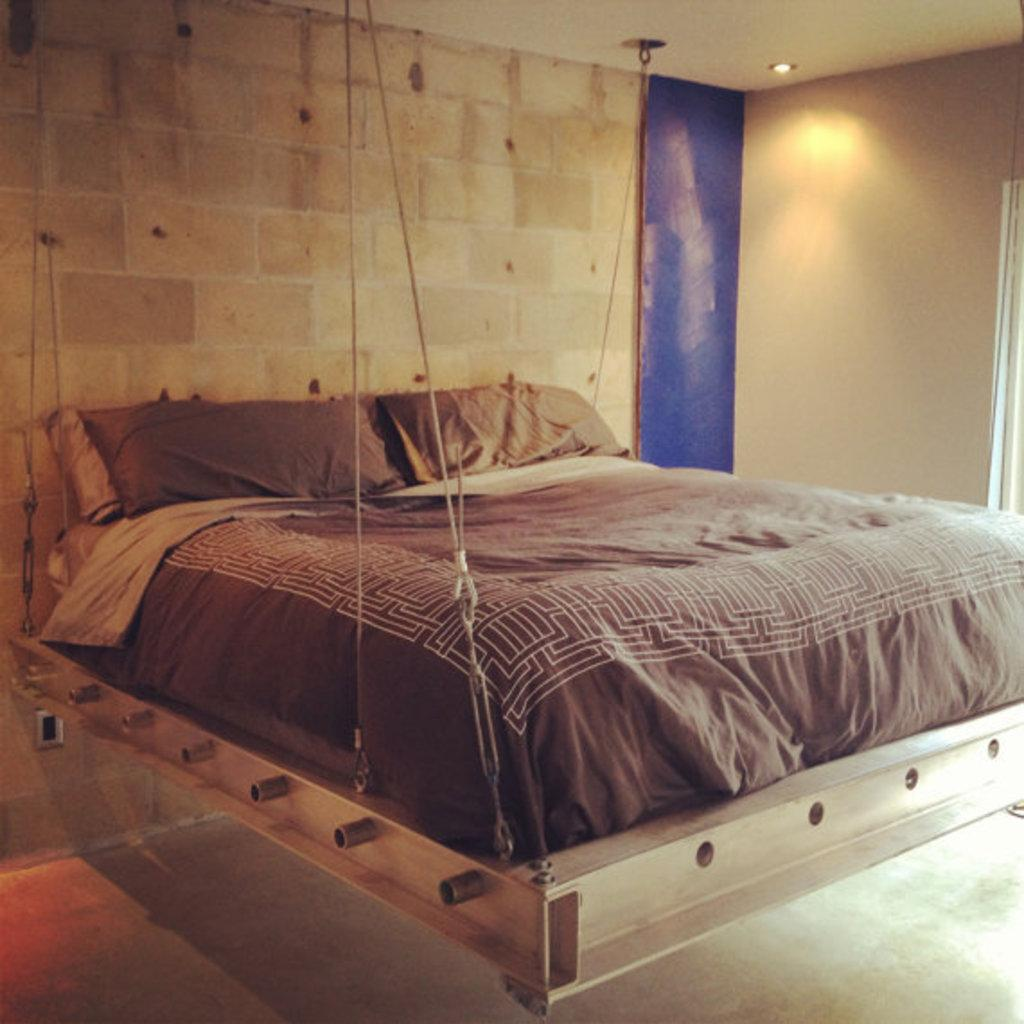What type of furniture is present in the picture? There is a bed in the picture. How is the bed supported? The bed is lifted by metal strings. What is on top of the bed? There is a mattress on the bed. Are there any accessories on the bed? Yes, there are pillows on the bed. Is there any source of light in the picture? Yes, there is a light on the roof. How does the yoke help the bed in the image? There is no yoke present in the image; the bed is supported by metal strings. 